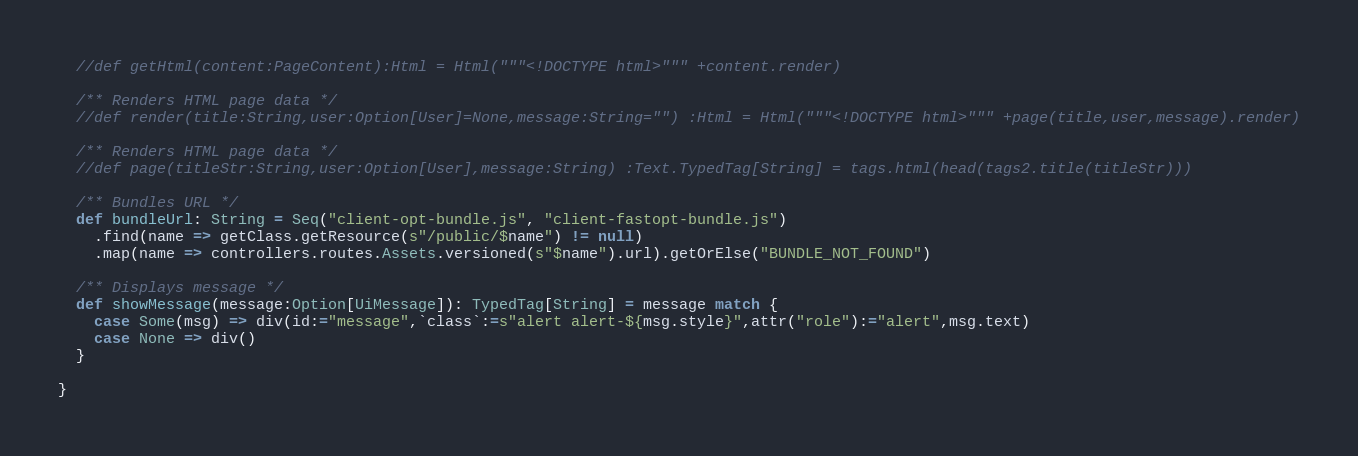Convert code to text. <code><loc_0><loc_0><loc_500><loc_500><_Scala_>  //def getHtml(content:PageContent):Html = Html("""<!DOCTYPE html>""" +content.render)

  /** Renders HTML page data */
  //def render(title:String,user:Option[User]=None,message:String="") :Html = Html("""<!DOCTYPE html>""" +page(title,user,message).render)

  /** Renders HTML page data */
  //def page(titleStr:String,user:Option[User],message:String) :Text.TypedTag[String] = tags.html(head(tags2.title(titleStr)))

  /** Bundles URL */
  def bundleUrl: String = Seq("client-opt-bundle.js", "client-fastopt-bundle.js")
    .find(name => getClass.getResource(s"/public/$name") != null)
    .map(name => controllers.routes.Assets.versioned(s"$name").url).getOrElse("BUNDLE_NOT_FOUND")

  /** Displays message */
  def showMessage(message:Option[UiMessage]): TypedTag[String] = message match {
    case Some(msg) => div(id:="message",`class`:=s"alert alert-${msg.style}",attr("role"):="alert",msg.text)
    case None => div()
  }

}</code> 